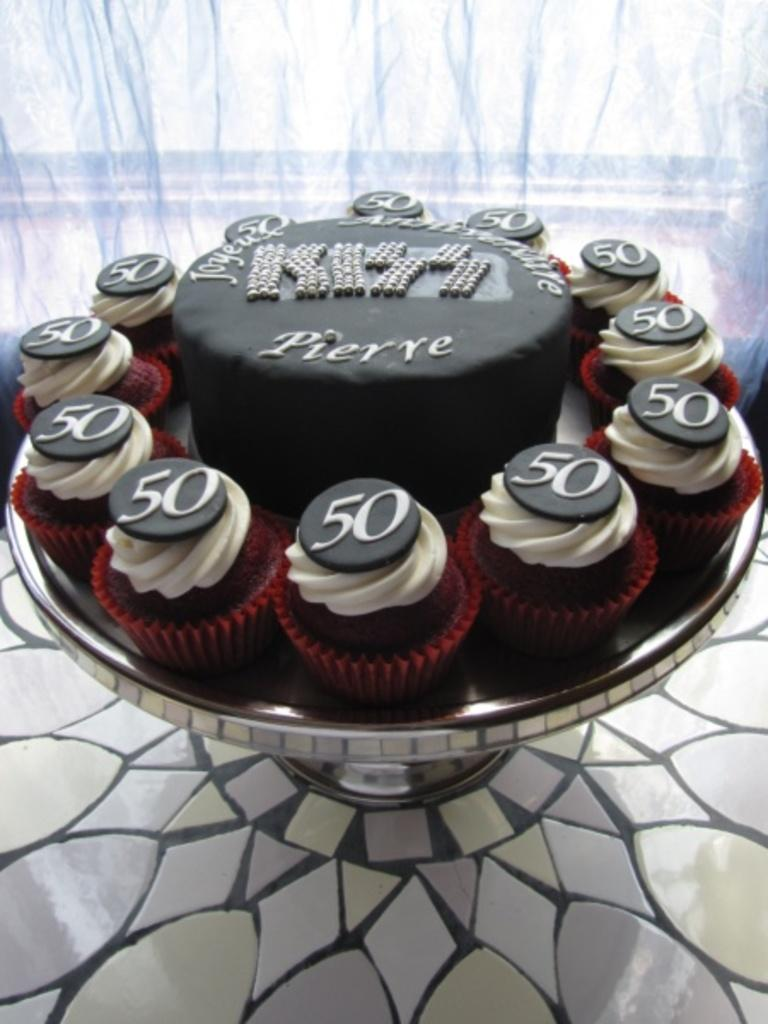What type of dessert is the main subject of the image? There is a cake in the image. Are there any other desserts visible in the image? Yes, there are cupcakes in the image. How are the cupcakes arranged or displayed? The cupcakes are on a stand. What number is written on the cupcakes? The number "50" is written on the cupcakes. What can be seen in the background of the image? There is a curtain in the background of the image. How many boats are visible in the image? There are no boats present in the image. What type of sticks are used to decorate the cake? There is no mention of sticks being used to decorate the cake in the image. 